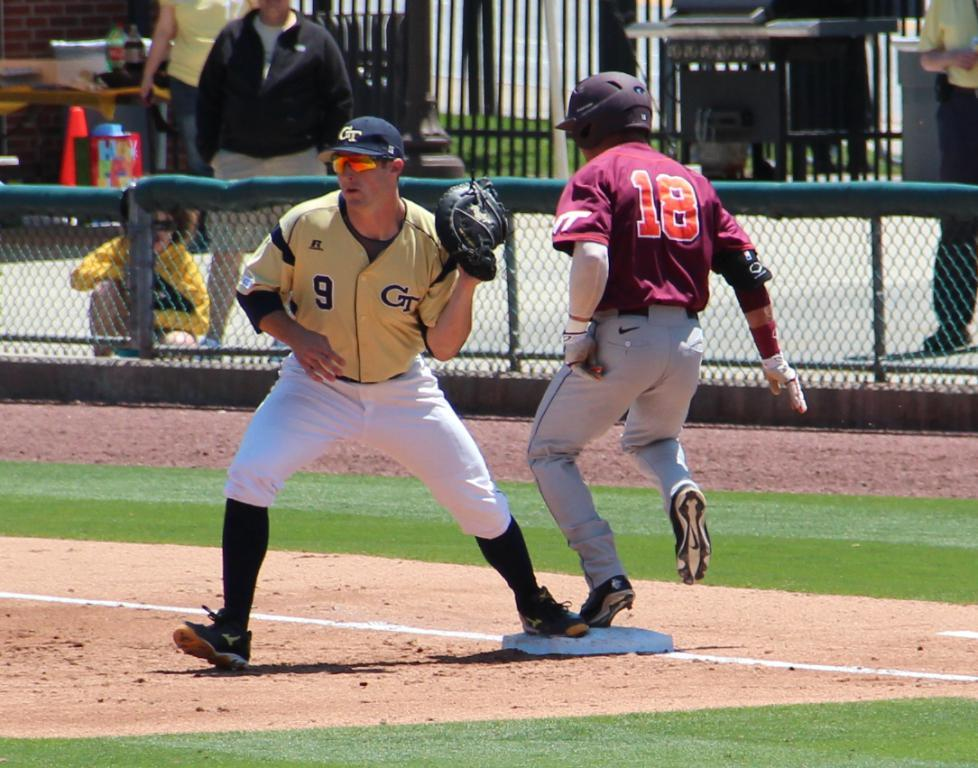How many people are present in the image? There are two people in the image. What can be seen in the background of the image? There is a mesh, people, and a table in the background of the image. What is on the table in the background? There are bottles on the table. Can you hear the record playing in the background of the image? There is no record or sound present in the image, as it is a still photograph. Is there a hen visible in the image? No, there is no hen present in the image. 